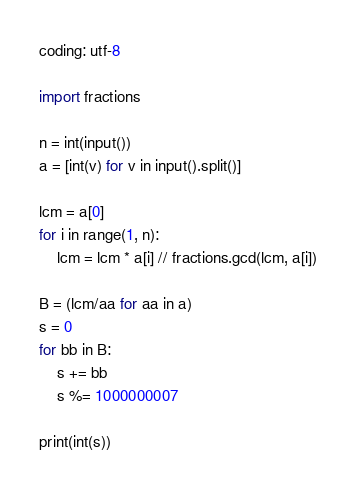Convert code to text. <code><loc_0><loc_0><loc_500><loc_500><_Python_>coding: utf-8

import fractions

n = int(input())
a = [int(v) for v in input().split()]

lcm = a[0]
for i in range(1, n):
    lcm = lcm * a[i] // fractions.gcd(lcm, a[i])

B = (lcm/aa for aa in a)
s = 0
for bb in B:
    s += bb
    s %= 1000000007

print(int(s))
</code> 